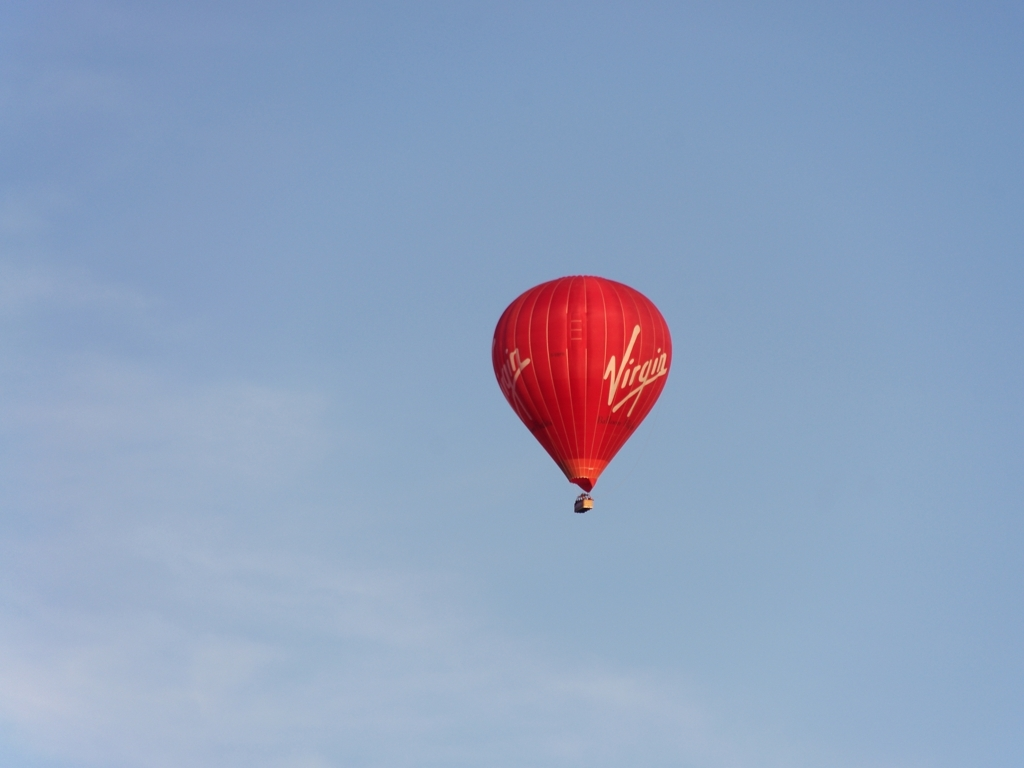What kind of balloon is shown in the image? The image features a hot air balloon, distinguished by its large red envelope and the 'Virgin' branding on it. Can you tell what time of day it might be? Based on the brightness of the sky and the position of the balloon, it appears to be taken during the day, likely late morning or early afternoon when the sky is clearest. 